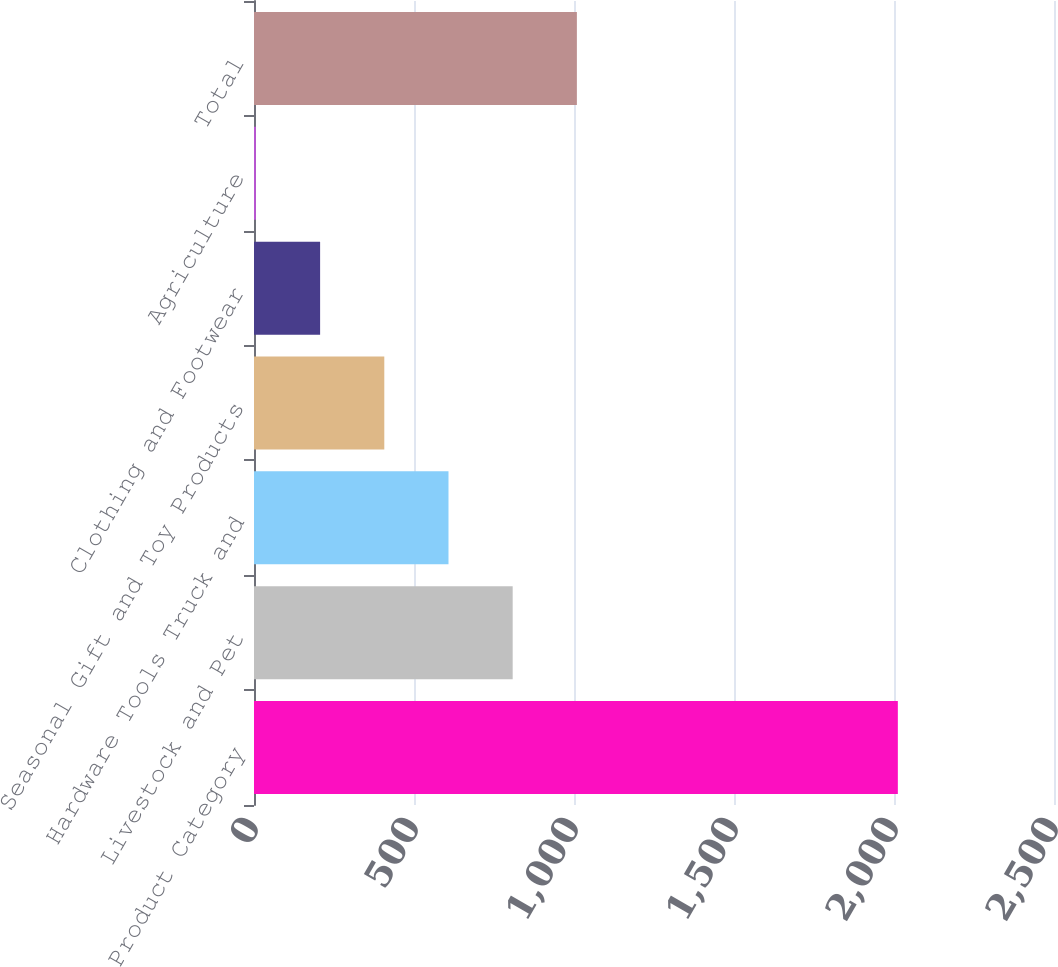<chart> <loc_0><loc_0><loc_500><loc_500><bar_chart><fcel>Product Category<fcel>Livestock and Pet<fcel>Hardware Tools Truck and<fcel>Seasonal Gift and Toy Products<fcel>Clothing and Footwear<fcel>Agriculture<fcel>Total<nl><fcel>2012<fcel>808.4<fcel>607.8<fcel>407.2<fcel>206.6<fcel>6<fcel>1009<nl></chart> 